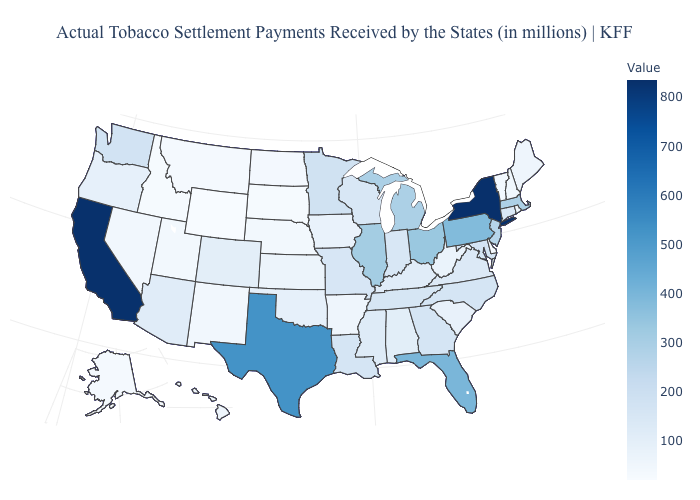Among the states that border Massachusetts , which have the lowest value?
Give a very brief answer. Vermont. Does New York have a lower value than Massachusetts?
Keep it brief. No. Among the states that border Virginia , does Maryland have the highest value?
Concise answer only. Yes. Does Massachusetts have the lowest value in the Northeast?
Keep it brief. No. Does Wyoming have a lower value than California?
Keep it brief. Yes. Does Oklahoma have the lowest value in the South?
Write a very short answer. No. 